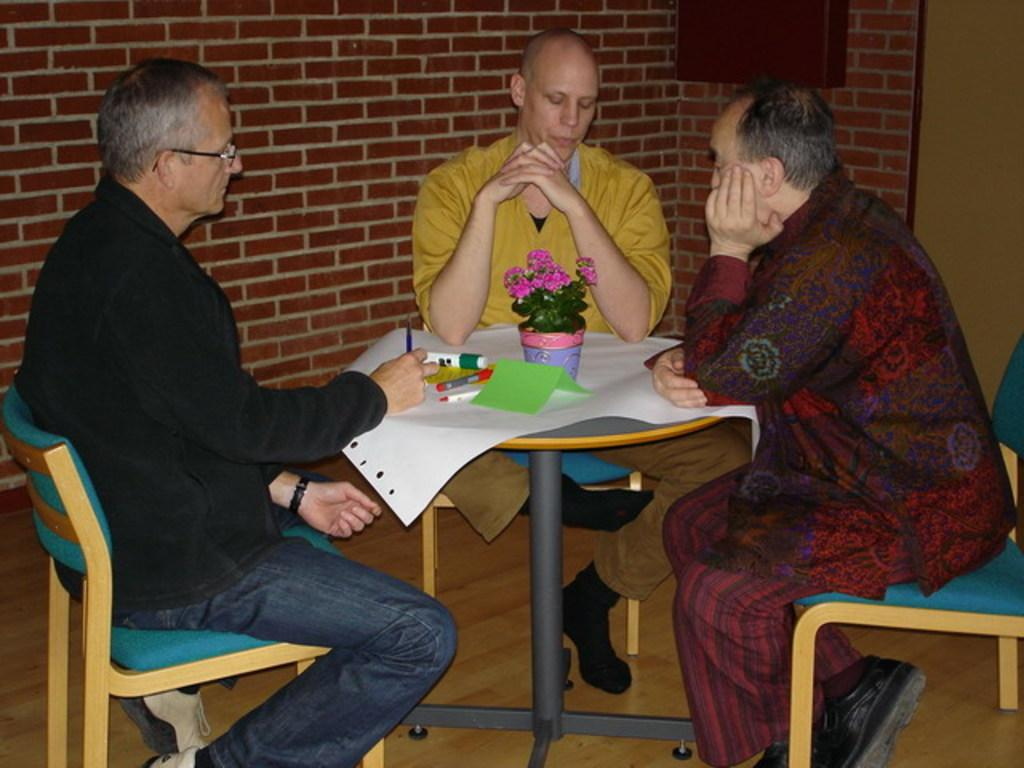How many people are sitting in chairs in the image? There are three members sitting in chairs in the image. What are the chairs arranged around? The chairs are arranged around a table. What is placed on the table? A paper and a flower vase are present on the table. What else can be seen on the table? There are papers and pens on the table. What is the gender of the members in the image? All three members are men. What is visible in the background of the image? There is a wall in the background. What type of glass is being used to measure the desire of the members in the image? There is no glass or measurement of desire present in the image. What shape is the table in the image? The shape of the table is not mentioned in the provided facts, so it cannot be determined from the image. 